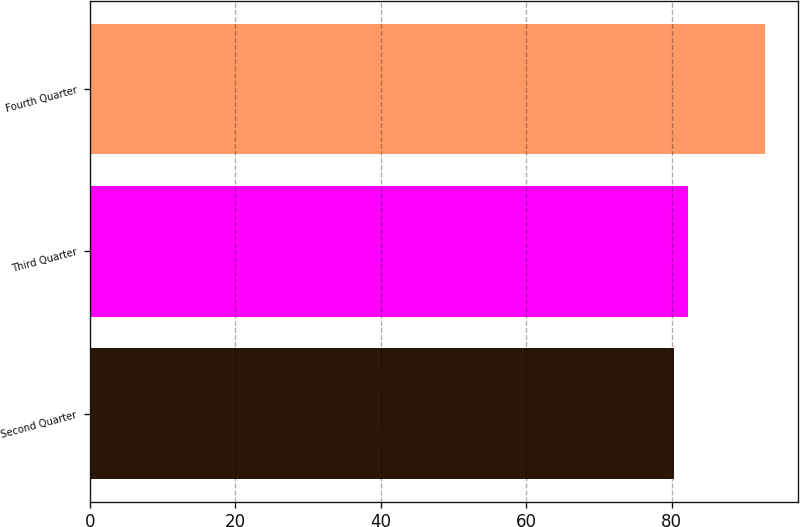Convert chart to OTSL. <chart><loc_0><loc_0><loc_500><loc_500><bar_chart><fcel>Second Quarter<fcel>Third Quarter<fcel>Fourth Quarter<nl><fcel>80.28<fcel>82.25<fcel>92.79<nl></chart> 